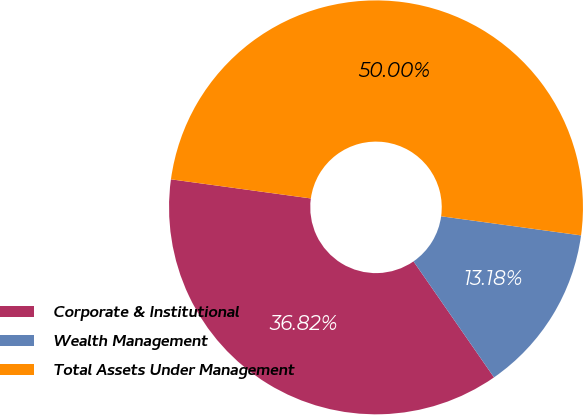Convert chart to OTSL. <chart><loc_0><loc_0><loc_500><loc_500><pie_chart><fcel>Corporate & Institutional<fcel>Wealth Management<fcel>Total Assets Under Management<nl><fcel>36.82%<fcel>13.18%<fcel>50.0%<nl></chart> 